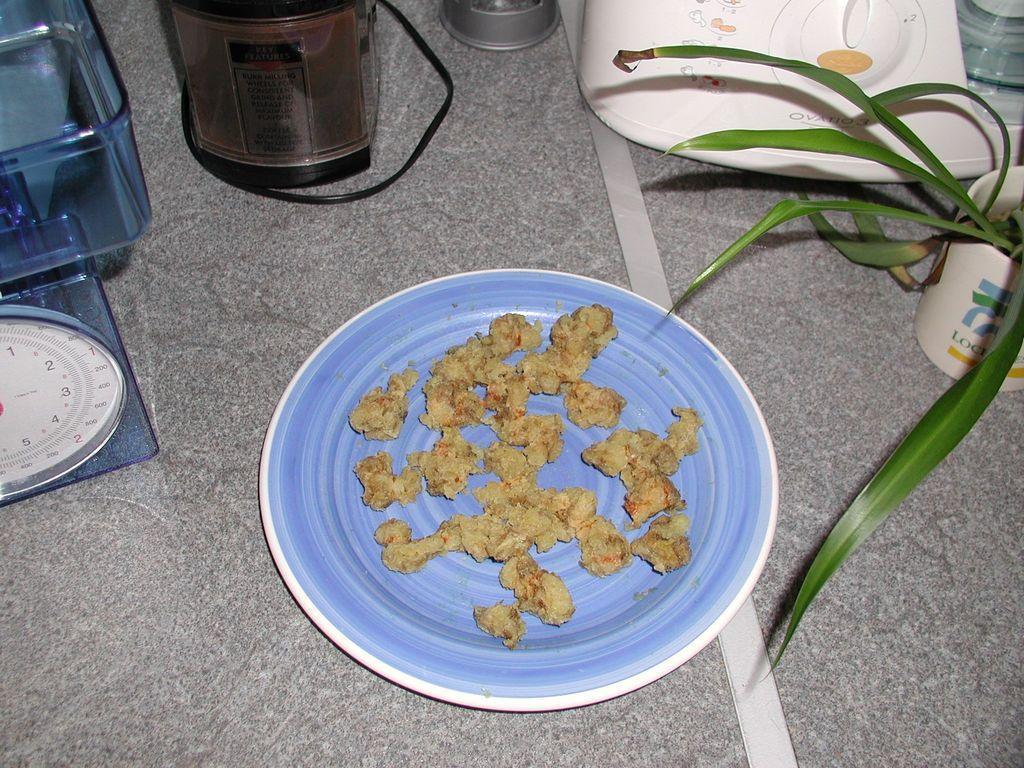In one or two sentences, can you explain what this image depicts? In this image, I can see a mixer, plate with a food item and few other objects, which are placed on the floor. I think this is a plant with the leaves. 